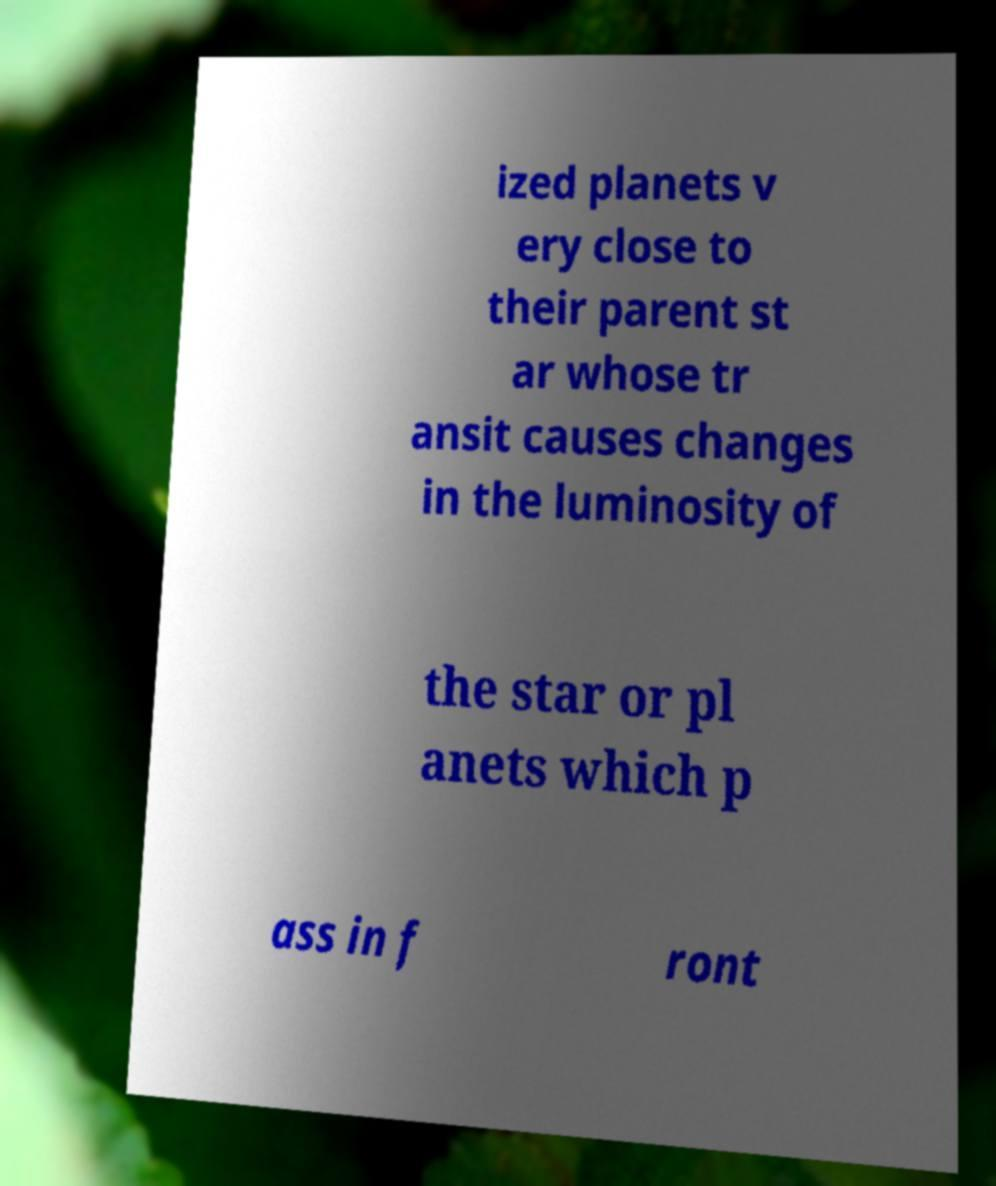For documentation purposes, I need the text within this image transcribed. Could you provide that? ized planets v ery close to their parent st ar whose tr ansit causes changes in the luminosity of the star or pl anets which p ass in f ront 